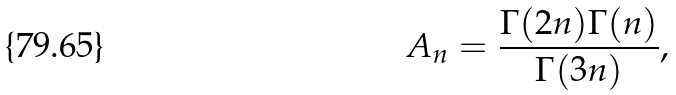Convert formula to latex. <formula><loc_0><loc_0><loc_500><loc_500>A _ { n } = \frac { \Gamma ( 2 n ) \Gamma ( n ) } { \Gamma ( 3 n ) } ,</formula> 